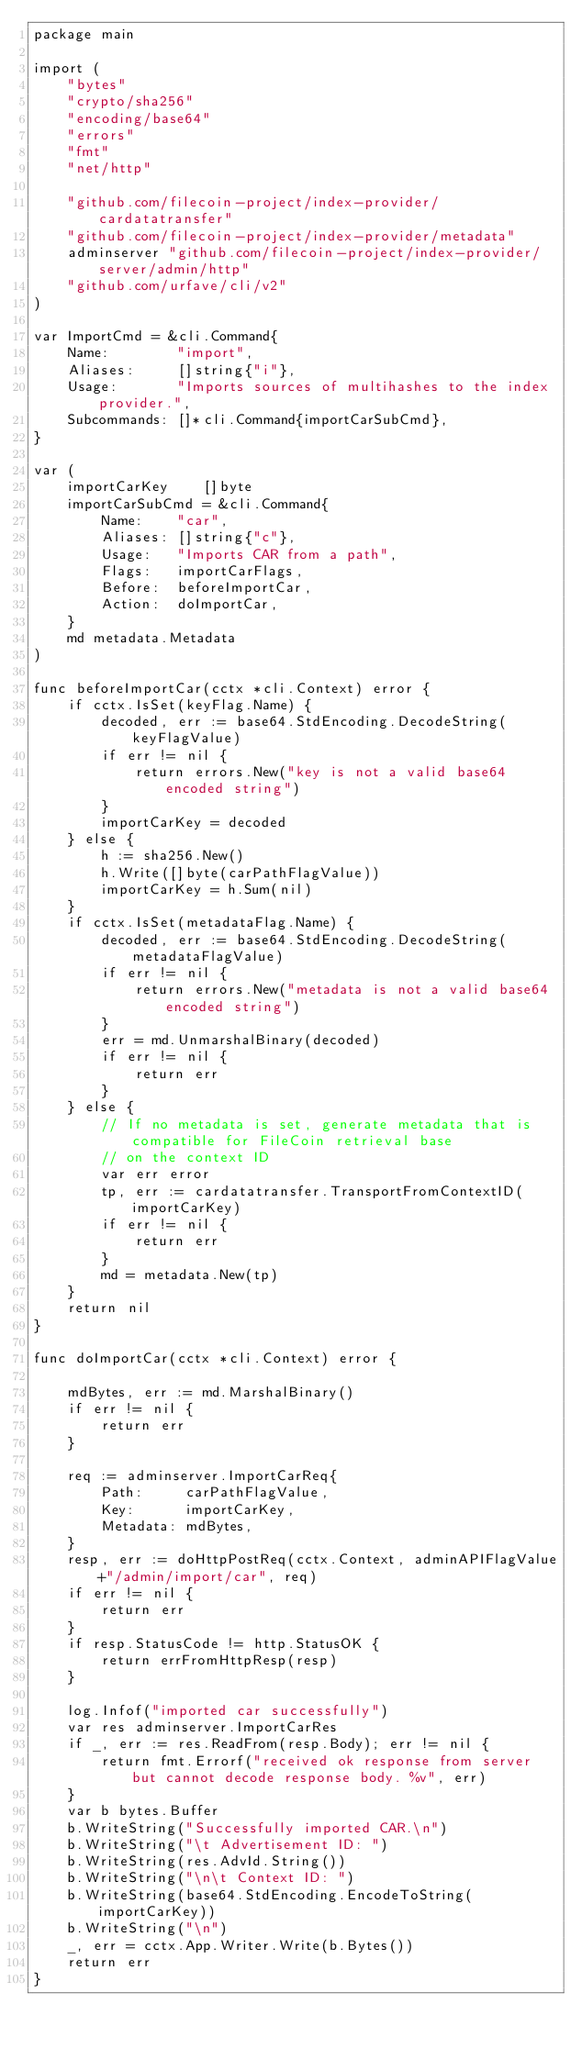<code> <loc_0><loc_0><loc_500><loc_500><_Go_>package main

import (
	"bytes"
	"crypto/sha256"
	"encoding/base64"
	"errors"
	"fmt"
	"net/http"

	"github.com/filecoin-project/index-provider/cardatatransfer"
	"github.com/filecoin-project/index-provider/metadata"
	adminserver "github.com/filecoin-project/index-provider/server/admin/http"
	"github.com/urfave/cli/v2"
)

var ImportCmd = &cli.Command{
	Name:        "import",
	Aliases:     []string{"i"},
	Usage:       "Imports sources of multihashes to the index provider.",
	Subcommands: []*cli.Command{importCarSubCmd},
}

var (
	importCarKey    []byte
	importCarSubCmd = &cli.Command{
		Name:    "car",
		Aliases: []string{"c"},
		Usage:   "Imports CAR from a path",
		Flags:   importCarFlags,
		Before:  beforeImportCar,
		Action:  doImportCar,
	}
	md metadata.Metadata
)

func beforeImportCar(cctx *cli.Context) error {
	if cctx.IsSet(keyFlag.Name) {
		decoded, err := base64.StdEncoding.DecodeString(keyFlagValue)
		if err != nil {
			return errors.New("key is not a valid base64 encoded string")
		}
		importCarKey = decoded
	} else {
		h := sha256.New()
		h.Write([]byte(carPathFlagValue))
		importCarKey = h.Sum(nil)
	}
	if cctx.IsSet(metadataFlag.Name) {
		decoded, err := base64.StdEncoding.DecodeString(metadataFlagValue)
		if err != nil {
			return errors.New("metadata is not a valid base64 encoded string")
		}
		err = md.UnmarshalBinary(decoded)
		if err != nil {
			return err
		}
	} else {
		// If no metadata is set, generate metadata that is compatible for FileCoin retrieval base
		// on the context ID
		var err error
		tp, err := cardatatransfer.TransportFromContextID(importCarKey)
		if err != nil {
			return err
		}
		md = metadata.New(tp)
	}
	return nil
}

func doImportCar(cctx *cli.Context) error {

	mdBytes, err := md.MarshalBinary()
	if err != nil {
		return err
	}

	req := adminserver.ImportCarReq{
		Path:     carPathFlagValue,
		Key:      importCarKey,
		Metadata: mdBytes,
	}
	resp, err := doHttpPostReq(cctx.Context, adminAPIFlagValue+"/admin/import/car", req)
	if err != nil {
		return err
	}
	if resp.StatusCode != http.StatusOK {
		return errFromHttpResp(resp)
	}

	log.Infof("imported car successfully")
	var res adminserver.ImportCarRes
	if _, err := res.ReadFrom(resp.Body); err != nil {
		return fmt.Errorf("received ok response from server but cannot decode response body. %v", err)
	}
	var b bytes.Buffer
	b.WriteString("Successfully imported CAR.\n")
	b.WriteString("\t Advertisement ID: ")
	b.WriteString(res.AdvId.String())
	b.WriteString("\n\t Context ID: ")
	b.WriteString(base64.StdEncoding.EncodeToString(importCarKey))
	b.WriteString("\n")
	_, err = cctx.App.Writer.Write(b.Bytes())
	return err
}
</code> 